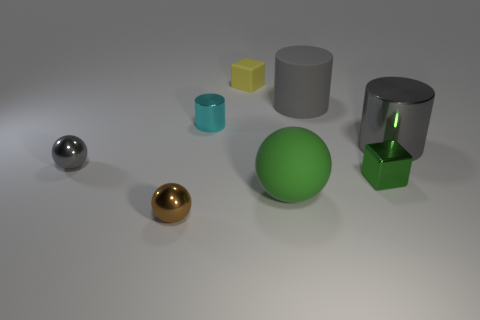Subtract all large cylinders. How many cylinders are left? 1 Add 2 large brown metal objects. How many objects exist? 10 Subtract all cylinders. How many objects are left? 5 Subtract all red shiny spheres. Subtract all green matte things. How many objects are left? 7 Add 6 brown balls. How many brown balls are left? 7 Add 6 brown metallic spheres. How many brown metallic spheres exist? 7 Subtract 0 blue balls. How many objects are left? 8 